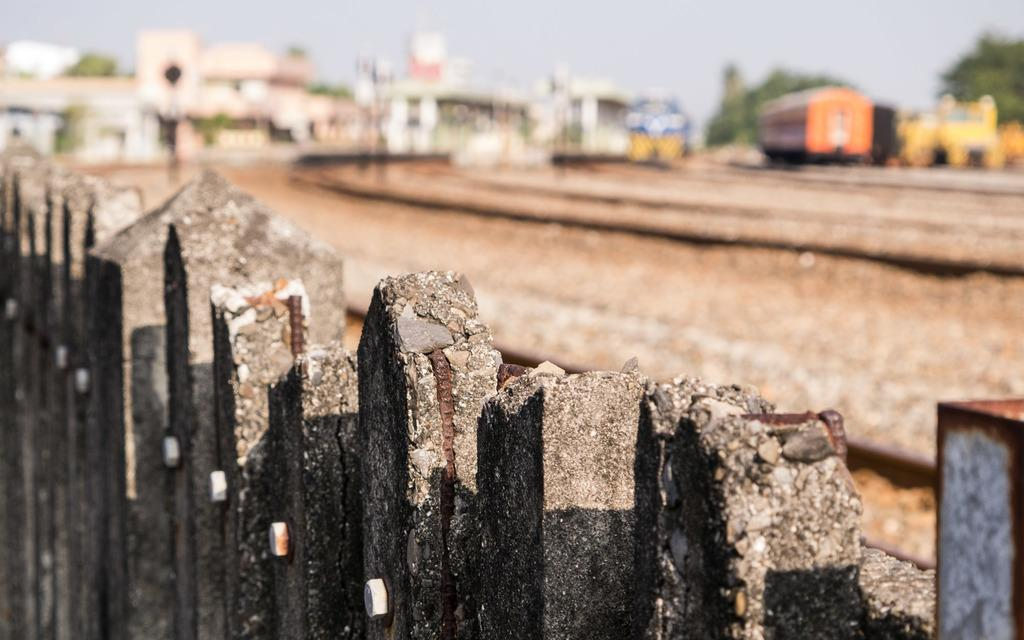What is located in the foreground of the image? There is a fencing in the foreground of the image. What can be seen in the background of the image? Houses, a railway track, a train, trees, and the sky are visible in the background of the image. Can you describe the railway track in the image? The railway track is present in the background of the image. What is the train doing in the image? The train is visible in the background of the image, but its specific actions are not discernible. Where is the fire burning in the image? There is no fire present in the image. What type of stove is visible in the image? There is no stove present in the image. 